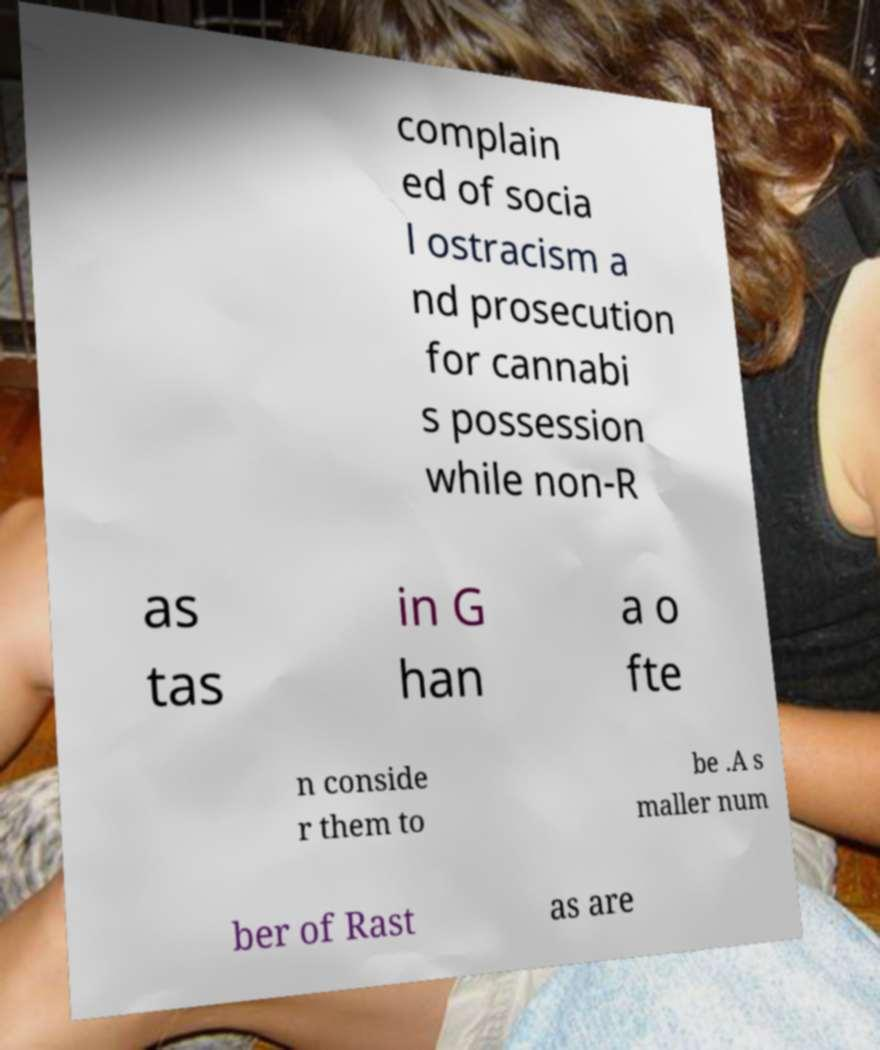Can you read and provide the text displayed in the image?This photo seems to have some interesting text. Can you extract and type it out for me? complain ed of socia l ostracism a nd prosecution for cannabi s possession while non-R as tas in G han a o fte n conside r them to be .A s maller num ber of Rast as are 